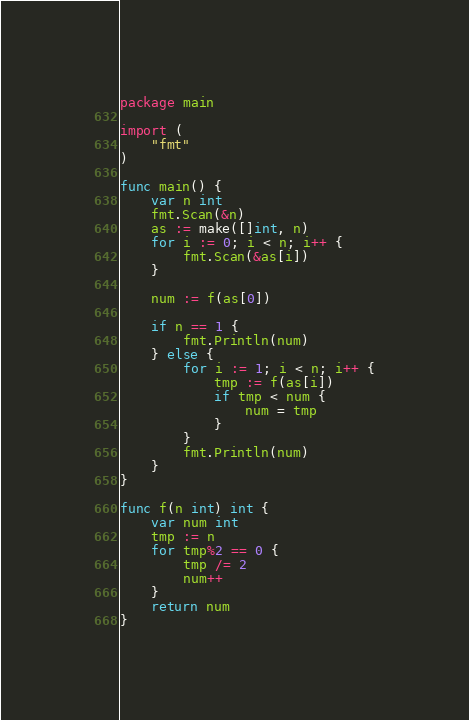Convert code to text. <code><loc_0><loc_0><loc_500><loc_500><_Go_>package main

import (
	"fmt"
)

func main() {
	var n int
	fmt.Scan(&n)
	as := make([]int, n)
	for i := 0; i < n; i++ {
		fmt.Scan(&as[i])
	}

	num := f(as[0])

	if n == 1 {
		fmt.Println(num)
	} else {
		for i := 1; i < n; i++ {
			tmp := f(as[i])
			if tmp < num {
				num = tmp
			}
		}
		fmt.Println(num)
	}
}

func f(n int) int {
	var num int
	tmp := n
	for tmp%2 == 0 {
		tmp /= 2
		num++
	}
	return num
}
</code> 